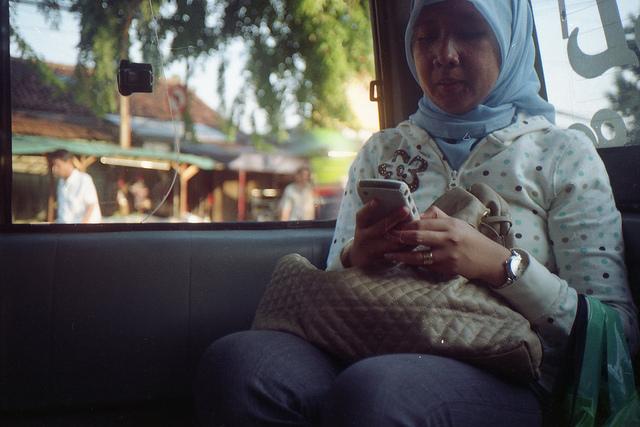How many human faces are visible in this picture?
Answer briefly. 3. What color is her watch?
Be succinct. Silver. What wrist is the woman's watch on?
Answer briefly. Left. What does the woman have on her head?
Be succinct. Scarf. Is this a smartphone?
Write a very short answer. Yes. 